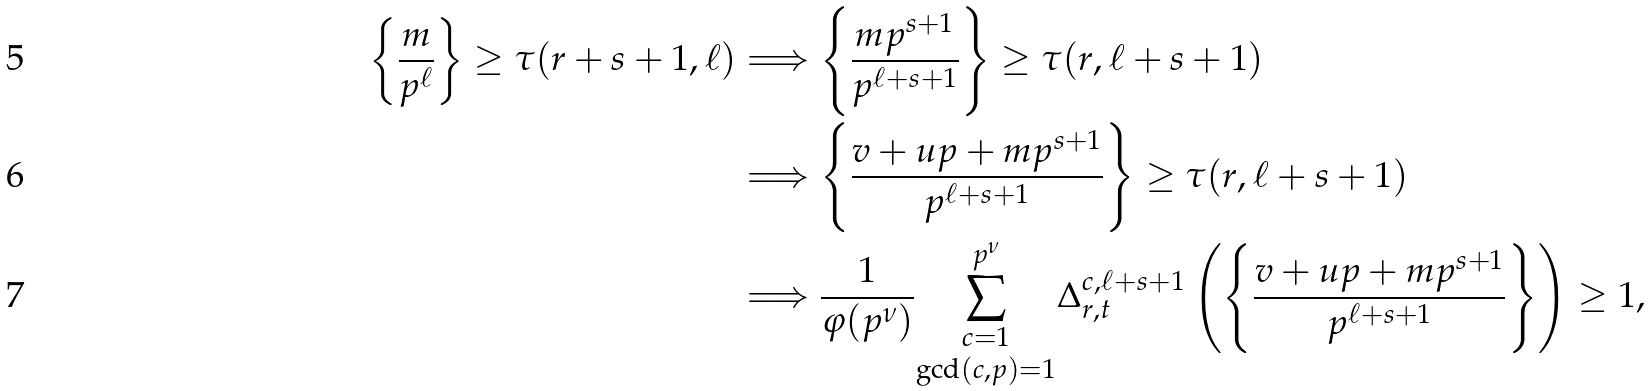Convert formula to latex. <formula><loc_0><loc_0><loc_500><loc_500>\left \{ \frac { m } { p ^ { \ell } } \right \} \geq \tau ( r + s + 1 , \ell ) & \Longrightarrow \left \{ \frac { m p ^ { s + 1 } } { p ^ { \ell + s + 1 } } \right \} \geq \tau ( r , \ell + s + 1 ) \\ & \Longrightarrow \left \{ \frac { v + u p + m p ^ { s + 1 } } { p ^ { \ell + s + 1 } } \right \} \geq \tau ( r , \ell + s + 1 ) \\ & \Longrightarrow \frac { 1 } { \varphi ( p ^ { \nu } ) } \underset { \gcd ( c , p ) = 1 } { \sum _ { c = 1 } ^ { p ^ { \nu } } } \Delta _ { r , t } ^ { c , \ell + s + 1 } \left ( \left \{ \frac { v + u p + m p ^ { s + 1 } } { p ^ { \ell + s + 1 } } \right \} \right ) \geq 1 ,</formula> 